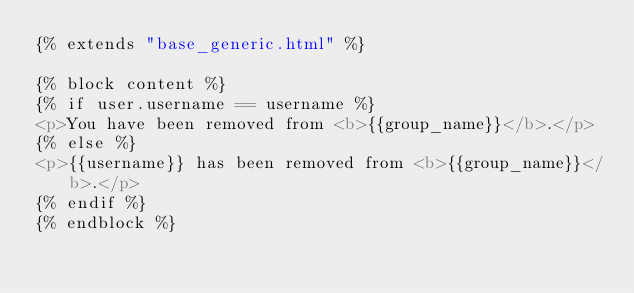Convert code to text. <code><loc_0><loc_0><loc_500><loc_500><_HTML_>{% extends "base_generic.html" %}

{% block content %}
{% if user.username == username %}
<p>You have been removed from <b>{{group_name}}</b>.</p>
{% else %}
<p>{{username}} has been removed from <b>{{group_name}}</b>.</p>
{% endif %}
{% endblock %}
</code> 